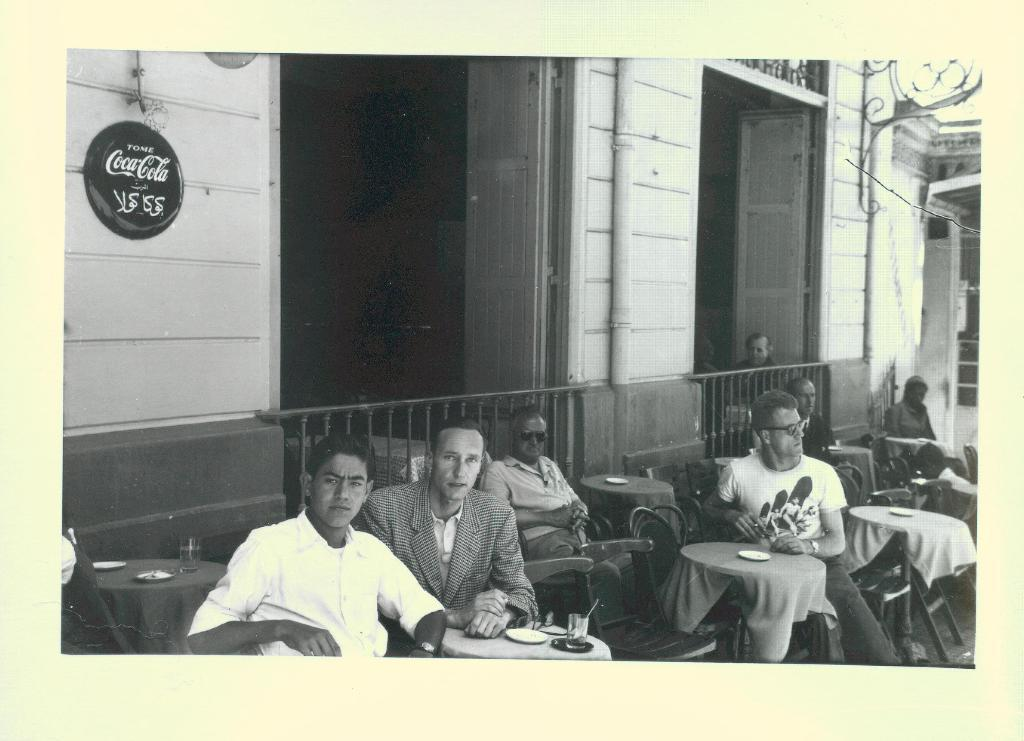What is the color scheme of the image? The image is black and white. What type of architectural feature can be seen in the image? There are doors in the image. Who or what is present in the image? There are persons in the image. What type of furniture is visible in the image? There are tables in the image. What type of objects can be seen on the tables? There are glasses in the image. What type of structure is depicted in the image? There is a building in the image. What part of the natural environment is visible in the image? There is sky visible in the image. How many slaves are visible in the image? There are no slaves present in the image. What type of rock can be seen in the image? There is no rock visible in the image. 